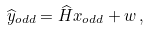<formula> <loc_0><loc_0><loc_500><loc_500>\widehat { y } _ { o d d } = \widehat { H } x _ { o d d } + w \, ,</formula> 